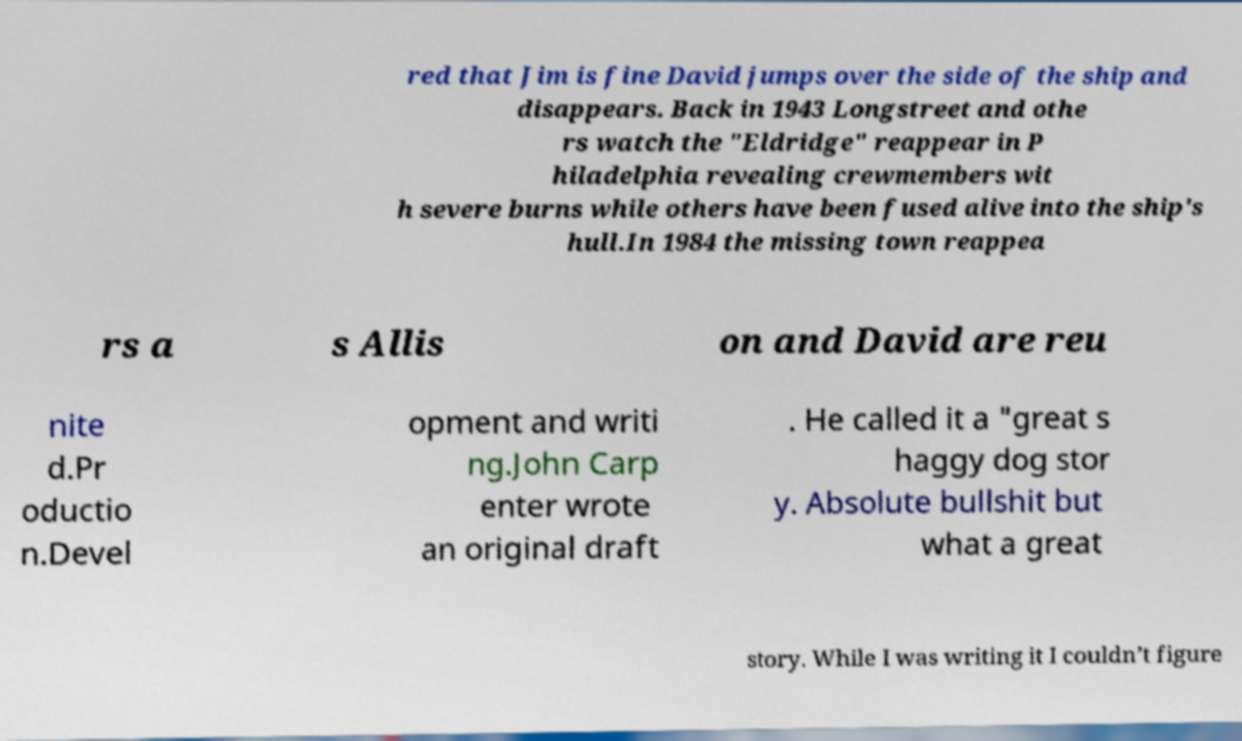What messages or text are displayed in this image? I need them in a readable, typed format. red that Jim is fine David jumps over the side of the ship and disappears. Back in 1943 Longstreet and othe rs watch the "Eldridge" reappear in P hiladelphia revealing crewmembers wit h severe burns while others have been fused alive into the ship's hull.In 1984 the missing town reappea rs a s Allis on and David are reu nite d.Pr oductio n.Devel opment and writi ng.John Carp enter wrote an original draft . He called it a "great s haggy dog stor y. Absolute bullshit but what a great story. While I was writing it I couldn’t figure 